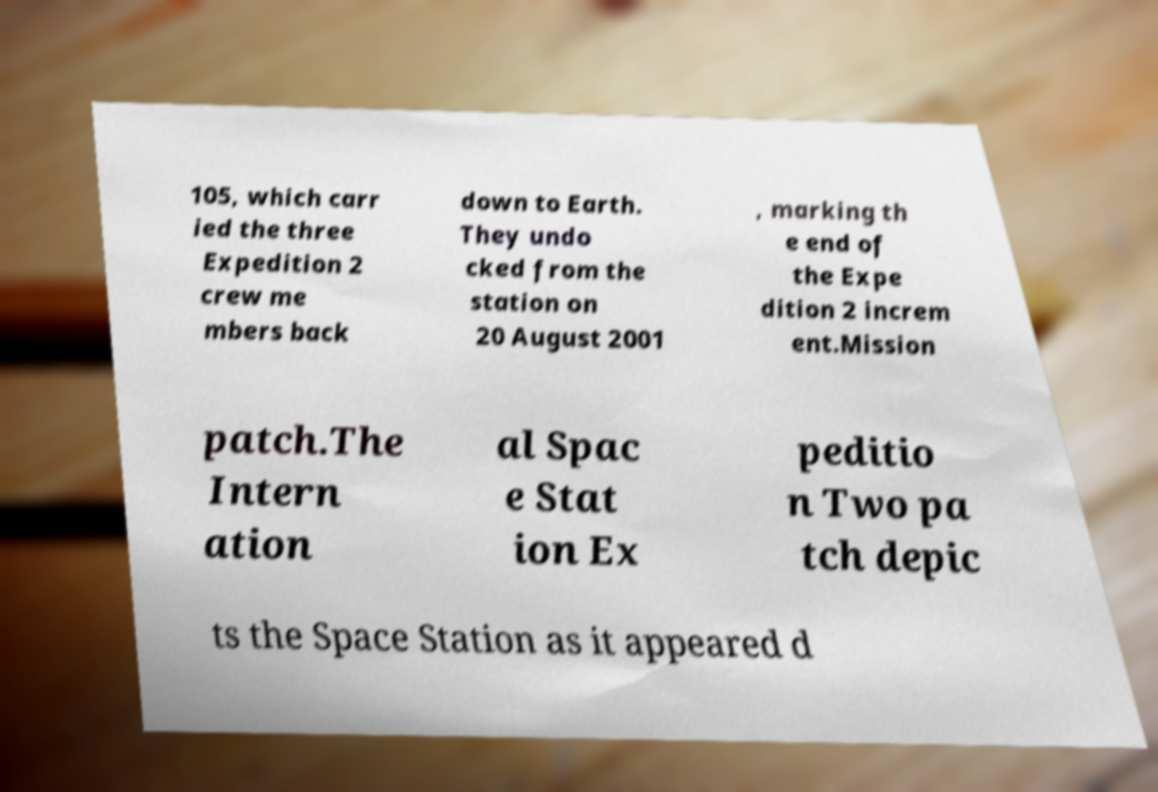What messages or text are displayed in this image? I need them in a readable, typed format. 105, which carr ied the three Expedition 2 crew me mbers back down to Earth. They undo cked from the station on 20 August 2001 , marking th e end of the Expe dition 2 increm ent.Mission patch.The Intern ation al Spac e Stat ion Ex peditio n Two pa tch depic ts the Space Station as it appeared d 